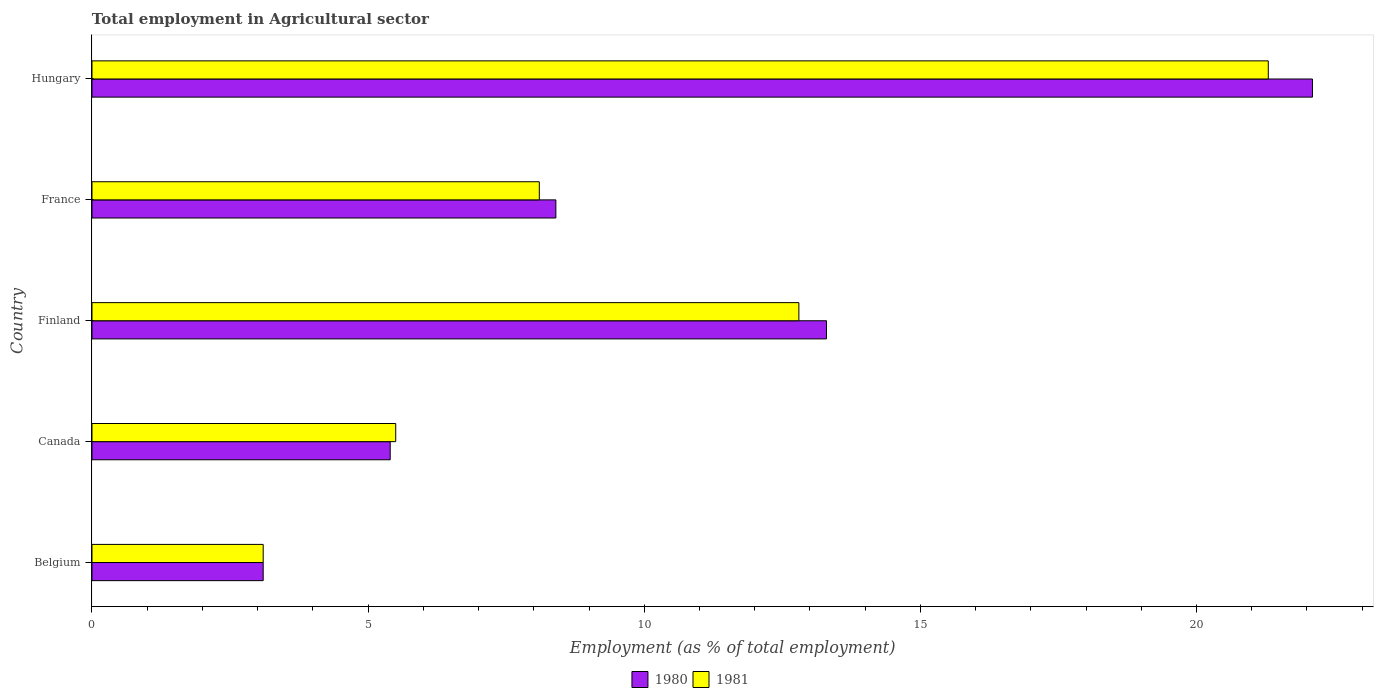How many different coloured bars are there?
Make the answer very short. 2. Are the number of bars per tick equal to the number of legend labels?
Ensure brevity in your answer.  Yes. How many bars are there on the 1st tick from the top?
Offer a terse response. 2. What is the label of the 1st group of bars from the top?
Offer a very short reply. Hungary. In how many cases, is the number of bars for a given country not equal to the number of legend labels?
Make the answer very short. 0. What is the employment in agricultural sector in 1981 in Belgium?
Your answer should be very brief. 3.1. Across all countries, what is the maximum employment in agricultural sector in 1980?
Ensure brevity in your answer.  22.1. Across all countries, what is the minimum employment in agricultural sector in 1980?
Your response must be concise. 3.1. In which country was the employment in agricultural sector in 1980 maximum?
Your response must be concise. Hungary. In which country was the employment in agricultural sector in 1980 minimum?
Ensure brevity in your answer.  Belgium. What is the total employment in agricultural sector in 1980 in the graph?
Provide a succinct answer. 52.3. What is the difference between the employment in agricultural sector in 1981 in Canada and that in Hungary?
Provide a short and direct response. -15.8. What is the difference between the employment in agricultural sector in 1980 in Belgium and the employment in agricultural sector in 1981 in Canada?
Provide a short and direct response. -2.4. What is the average employment in agricultural sector in 1980 per country?
Your answer should be compact. 10.46. What is the difference between the employment in agricultural sector in 1981 and employment in agricultural sector in 1980 in Hungary?
Offer a terse response. -0.8. What is the ratio of the employment in agricultural sector in 1981 in Belgium to that in Hungary?
Provide a succinct answer. 0.15. Is the employment in agricultural sector in 1980 in France less than that in Hungary?
Provide a succinct answer. Yes. Is the difference between the employment in agricultural sector in 1981 in Canada and France greater than the difference between the employment in agricultural sector in 1980 in Canada and France?
Offer a very short reply. Yes. What is the difference between the highest and the second highest employment in agricultural sector in 1981?
Your response must be concise. 8.5. What is the difference between the highest and the lowest employment in agricultural sector in 1981?
Your answer should be compact. 18.2. Is the sum of the employment in agricultural sector in 1981 in Belgium and Canada greater than the maximum employment in agricultural sector in 1980 across all countries?
Make the answer very short. No. What does the 1st bar from the top in Hungary represents?
Provide a succinct answer. 1981. What does the 2nd bar from the bottom in Finland represents?
Provide a succinct answer. 1981. How many bars are there?
Your answer should be very brief. 10. Are all the bars in the graph horizontal?
Your answer should be very brief. Yes. How many countries are there in the graph?
Provide a short and direct response. 5. What is the difference between two consecutive major ticks on the X-axis?
Your answer should be compact. 5. Does the graph contain any zero values?
Provide a succinct answer. No. Does the graph contain grids?
Keep it short and to the point. No. Where does the legend appear in the graph?
Provide a succinct answer. Bottom center. How many legend labels are there?
Ensure brevity in your answer.  2. What is the title of the graph?
Your answer should be very brief. Total employment in Agricultural sector. What is the label or title of the X-axis?
Your answer should be compact. Employment (as % of total employment). What is the label or title of the Y-axis?
Offer a very short reply. Country. What is the Employment (as % of total employment) in 1980 in Belgium?
Offer a terse response. 3.1. What is the Employment (as % of total employment) in 1981 in Belgium?
Provide a short and direct response. 3.1. What is the Employment (as % of total employment) in 1980 in Canada?
Offer a terse response. 5.4. What is the Employment (as % of total employment) in 1980 in Finland?
Your response must be concise. 13.3. What is the Employment (as % of total employment) in 1981 in Finland?
Your response must be concise. 12.8. What is the Employment (as % of total employment) of 1980 in France?
Ensure brevity in your answer.  8.4. What is the Employment (as % of total employment) of 1981 in France?
Keep it short and to the point. 8.1. What is the Employment (as % of total employment) in 1980 in Hungary?
Offer a very short reply. 22.1. What is the Employment (as % of total employment) of 1981 in Hungary?
Your answer should be very brief. 21.3. Across all countries, what is the maximum Employment (as % of total employment) in 1980?
Keep it short and to the point. 22.1. Across all countries, what is the maximum Employment (as % of total employment) of 1981?
Offer a very short reply. 21.3. Across all countries, what is the minimum Employment (as % of total employment) in 1980?
Make the answer very short. 3.1. Across all countries, what is the minimum Employment (as % of total employment) in 1981?
Your response must be concise. 3.1. What is the total Employment (as % of total employment) in 1980 in the graph?
Give a very brief answer. 52.3. What is the total Employment (as % of total employment) in 1981 in the graph?
Your answer should be compact. 50.8. What is the difference between the Employment (as % of total employment) of 1981 in Belgium and that in Canada?
Your answer should be very brief. -2.4. What is the difference between the Employment (as % of total employment) in 1980 in Belgium and that in Finland?
Provide a short and direct response. -10.2. What is the difference between the Employment (as % of total employment) of 1981 in Belgium and that in Finland?
Keep it short and to the point. -9.7. What is the difference between the Employment (as % of total employment) of 1980 in Belgium and that in France?
Provide a succinct answer. -5.3. What is the difference between the Employment (as % of total employment) in 1981 in Belgium and that in France?
Ensure brevity in your answer.  -5. What is the difference between the Employment (as % of total employment) of 1981 in Belgium and that in Hungary?
Provide a succinct answer. -18.2. What is the difference between the Employment (as % of total employment) of 1980 in Canada and that in France?
Your answer should be very brief. -3. What is the difference between the Employment (as % of total employment) in 1981 in Canada and that in France?
Keep it short and to the point. -2.6. What is the difference between the Employment (as % of total employment) in 1980 in Canada and that in Hungary?
Your answer should be very brief. -16.7. What is the difference between the Employment (as % of total employment) in 1981 in Canada and that in Hungary?
Provide a succinct answer. -15.8. What is the difference between the Employment (as % of total employment) in 1980 in France and that in Hungary?
Offer a terse response. -13.7. What is the difference between the Employment (as % of total employment) of 1981 in France and that in Hungary?
Offer a very short reply. -13.2. What is the difference between the Employment (as % of total employment) of 1980 in Belgium and the Employment (as % of total employment) of 1981 in Finland?
Provide a short and direct response. -9.7. What is the difference between the Employment (as % of total employment) of 1980 in Belgium and the Employment (as % of total employment) of 1981 in France?
Your response must be concise. -5. What is the difference between the Employment (as % of total employment) in 1980 in Belgium and the Employment (as % of total employment) in 1981 in Hungary?
Provide a short and direct response. -18.2. What is the difference between the Employment (as % of total employment) of 1980 in Canada and the Employment (as % of total employment) of 1981 in Finland?
Your answer should be compact. -7.4. What is the difference between the Employment (as % of total employment) of 1980 in Canada and the Employment (as % of total employment) of 1981 in France?
Give a very brief answer. -2.7. What is the difference between the Employment (as % of total employment) in 1980 in Canada and the Employment (as % of total employment) in 1981 in Hungary?
Your answer should be very brief. -15.9. What is the difference between the Employment (as % of total employment) of 1980 in France and the Employment (as % of total employment) of 1981 in Hungary?
Provide a succinct answer. -12.9. What is the average Employment (as % of total employment) in 1980 per country?
Your answer should be very brief. 10.46. What is the average Employment (as % of total employment) in 1981 per country?
Make the answer very short. 10.16. What is the difference between the Employment (as % of total employment) in 1980 and Employment (as % of total employment) in 1981 in Belgium?
Offer a very short reply. 0. What is the difference between the Employment (as % of total employment) of 1980 and Employment (as % of total employment) of 1981 in Canada?
Make the answer very short. -0.1. What is the difference between the Employment (as % of total employment) in 1980 and Employment (as % of total employment) in 1981 in Hungary?
Offer a terse response. 0.8. What is the ratio of the Employment (as % of total employment) of 1980 in Belgium to that in Canada?
Provide a short and direct response. 0.57. What is the ratio of the Employment (as % of total employment) in 1981 in Belgium to that in Canada?
Provide a short and direct response. 0.56. What is the ratio of the Employment (as % of total employment) in 1980 in Belgium to that in Finland?
Make the answer very short. 0.23. What is the ratio of the Employment (as % of total employment) of 1981 in Belgium to that in Finland?
Your answer should be very brief. 0.24. What is the ratio of the Employment (as % of total employment) of 1980 in Belgium to that in France?
Offer a very short reply. 0.37. What is the ratio of the Employment (as % of total employment) in 1981 in Belgium to that in France?
Give a very brief answer. 0.38. What is the ratio of the Employment (as % of total employment) of 1980 in Belgium to that in Hungary?
Make the answer very short. 0.14. What is the ratio of the Employment (as % of total employment) in 1981 in Belgium to that in Hungary?
Provide a short and direct response. 0.15. What is the ratio of the Employment (as % of total employment) in 1980 in Canada to that in Finland?
Provide a short and direct response. 0.41. What is the ratio of the Employment (as % of total employment) of 1981 in Canada to that in Finland?
Your answer should be compact. 0.43. What is the ratio of the Employment (as % of total employment) of 1980 in Canada to that in France?
Your response must be concise. 0.64. What is the ratio of the Employment (as % of total employment) of 1981 in Canada to that in France?
Provide a short and direct response. 0.68. What is the ratio of the Employment (as % of total employment) of 1980 in Canada to that in Hungary?
Your response must be concise. 0.24. What is the ratio of the Employment (as % of total employment) of 1981 in Canada to that in Hungary?
Ensure brevity in your answer.  0.26. What is the ratio of the Employment (as % of total employment) in 1980 in Finland to that in France?
Your answer should be compact. 1.58. What is the ratio of the Employment (as % of total employment) of 1981 in Finland to that in France?
Give a very brief answer. 1.58. What is the ratio of the Employment (as % of total employment) in 1980 in Finland to that in Hungary?
Your answer should be compact. 0.6. What is the ratio of the Employment (as % of total employment) in 1981 in Finland to that in Hungary?
Give a very brief answer. 0.6. What is the ratio of the Employment (as % of total employment) of 1980 in France to that in Hungary?
Provide a short and direct response. 0.38. What is the ratio of the Employment (as % of total employment) of 1981 in France to that in Hungary?
Your response must be concise. 0.38. What is the difference between the highest and the second highest Employment (as % of total employment) in 1980?
Your response must be concise. 8.8. What is the difference between the highest and the lowest Employment (as % of total employment) of 1981?
Provide a succinct answer. 18.2. 